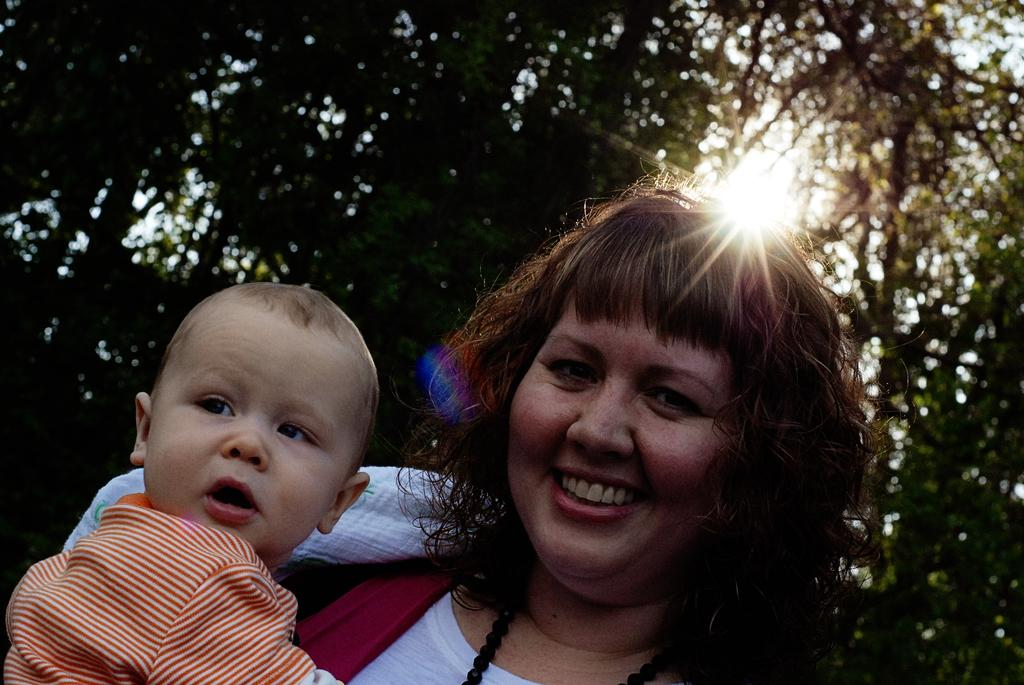Who is the main subject in the image? There is a woman in the image. What is the woman doing in the image? The woman is holding a baby. What type of natural environment can be seen in the image? There are trees visible in the image. What is the source of light in the image? Sunlight is present in the image. What activity are the boys participating in the image? There are no boys present in the image; it features a woman holding a baby. What type of flesh can be seen on the baby in the image? There is no flesh visible on the baby in the image; it is fully clothed. 